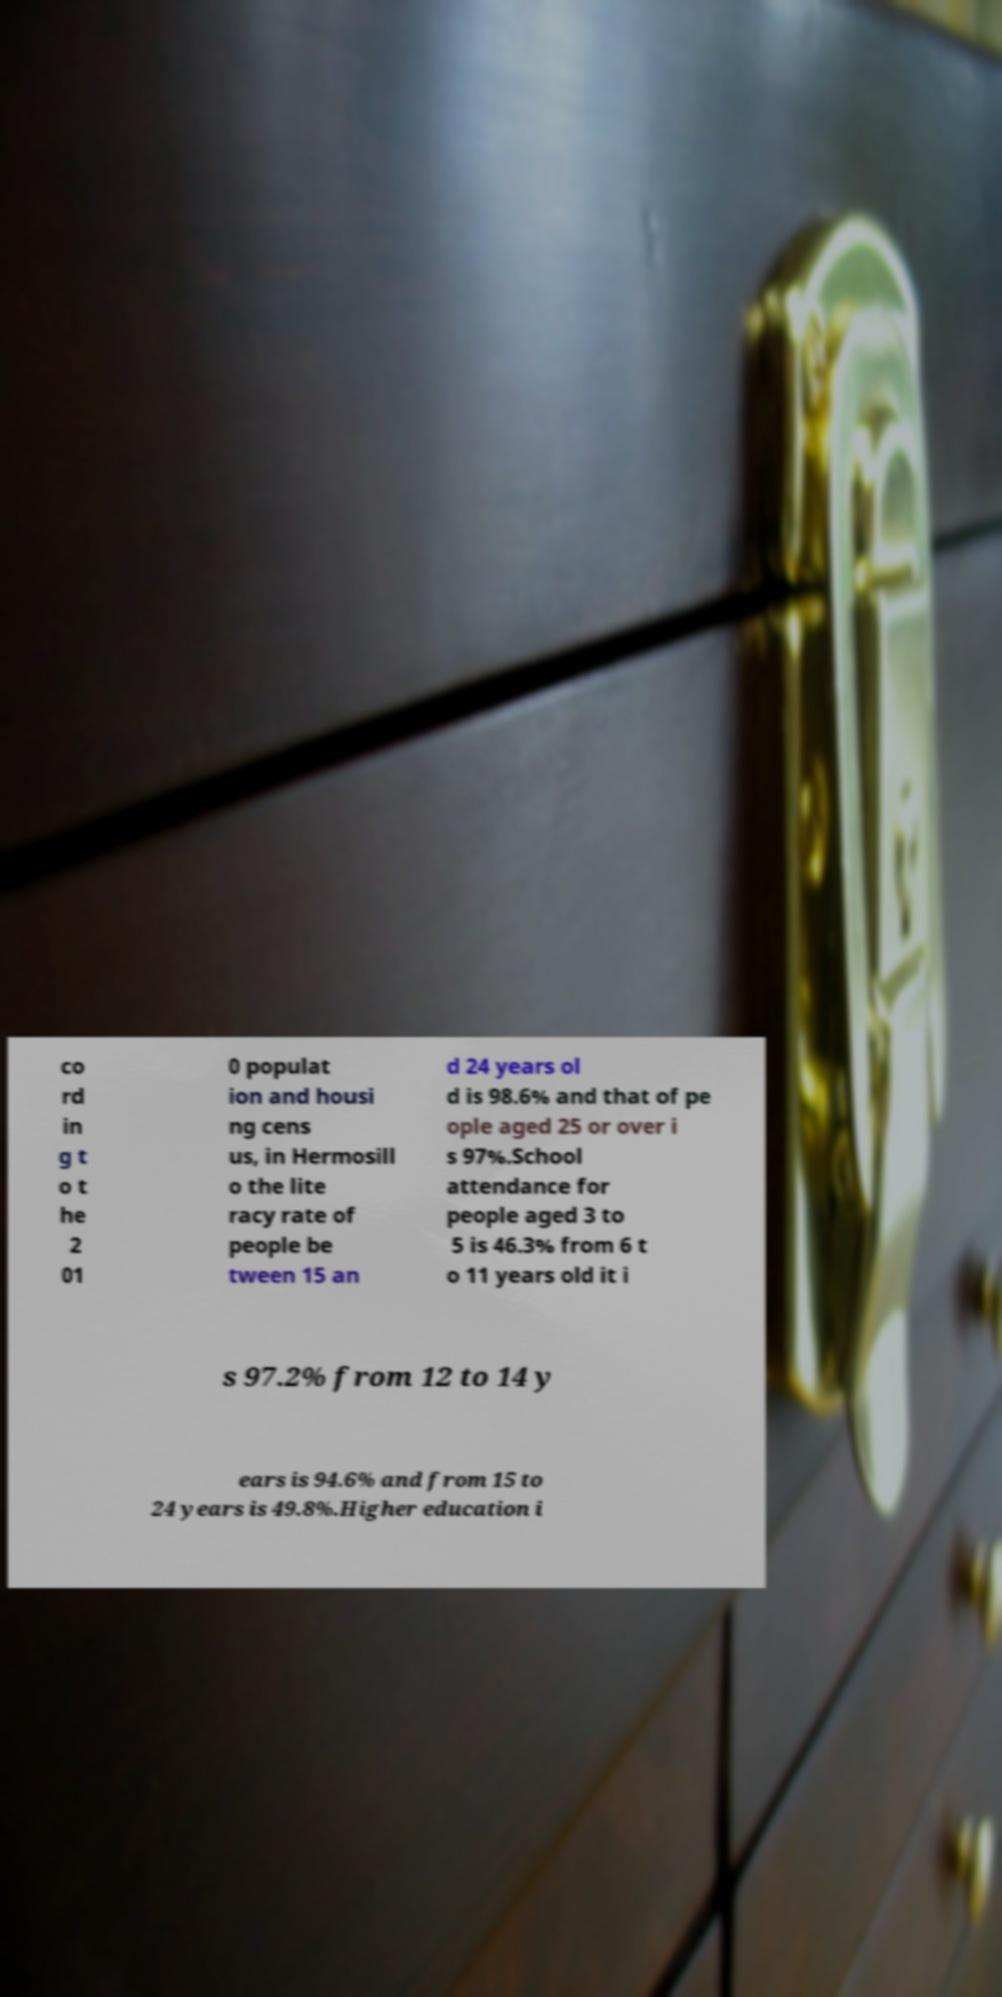Could you assist in decoding the text presented in this image and type it out clearly? co rd in g t o t he 2 01 0 populat ion and housi ng cens us, in Hermosill o the lite racy rate of people be tween 15 an d 24 years ol d is 98.6% and that of pe ople aged 25 or over i s 97%.School attendance for people aged 3 to 5 is 46.3% from 6 t o 11 years old it i s 97.2% from 12 to 14 y ears is 94.6% and from 15 to 24 years is 49.8%.Higher education i 